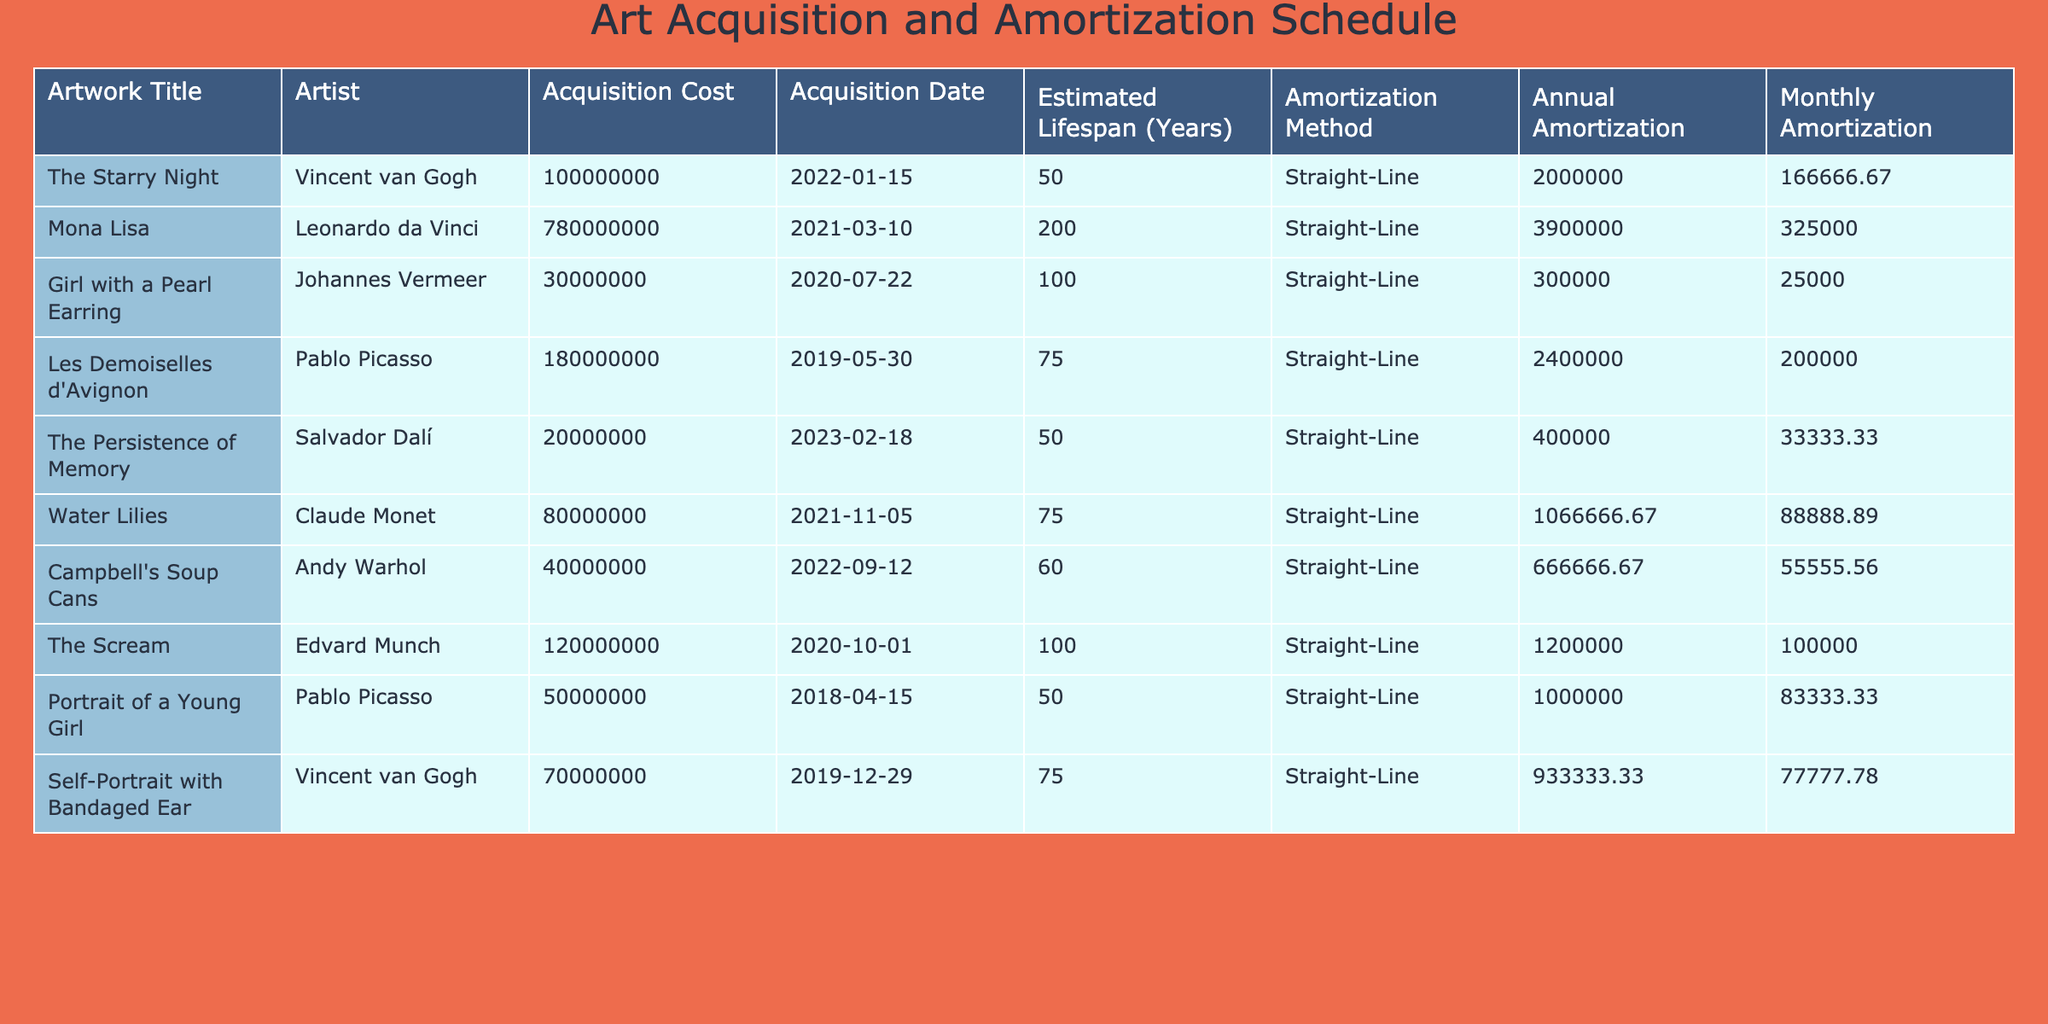What is the acquisition cost of "The Starry Night"? The table lists the acquisition cost under the "Acquisition Cost" column for each artwork. For "The Starry Night," the value is 100000000.
Answer: 100000000 What is the annual amortization for the "Mona Lisa"? To find the annual amortization, refer to the "Annual Amortization" column associated with "Mona Lisa" in the table. The value is 3900000.
Answer: 3900000 Which artwork has the highest estimated lifespan? Comparing the "Estimated Lifespan (Years)" for all artworks, "Mona Lisa" has the highest value at 200 years.
Answer: Mona Lisa What is the total acquisition cost of the artworks listed? Sum the "Acquisition Cost" values: 100000000 + 780000000 + 30000000 + 180000000 + 20000000 + 80000000 + 40000000 + 120000000 + 50000000 + 70000000 = 1500000000.
Answer: 1500000000 Is the annual amortization for "The Scream" higher than that of "Girl with a Pearl Earring"? Comparing the values, "The Scream" has an annual amortization of 1200000 and "Girl with a Pearl Earring" has 300000. Since 1200000 is greater than 300000, the statement is true.
Answer: Yes What is the difference between the monthly amortization of "Water Lilies" and "The Persistence of Memory"? The monthly amortization for "Water Lilies" is 88888.89 and for "The Persistence of Memory" it is 33333.33. The difference is 88888.89 - 33333.33 = 55555.56.
Answer: 55555.56 Which artist's works have an acquisition cost greater than 50000000? By checking the "Acquisition Cost" values, the artworks by Vincent van Gogh, Leonardo da Vinci, Pablo Picasso, and Claude Monet have costs greater than 50000000.
Answer: Vincent van Gogh, Leonardo da Vinci, Pablo Picasso, Claude Monet What is the average annual amortization for the artworks listed? First, sum the annual amortizations: 2000000 + 3900000 + 300000 + 2400000 + 400000 + 1066666.67 + 666666.67 + 1200000 + 1000000 + 933333.33 = 13800000. There are 10 artworks, so the average is 13800000 / 10 = 1380000.
Answer: 1380000 